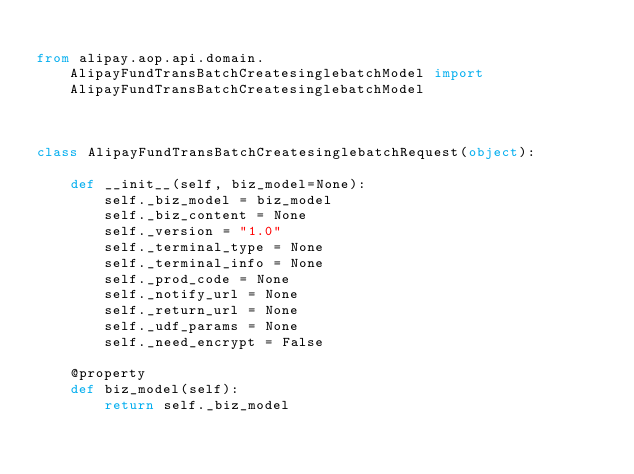Convert code to text. <code><loc_0><loc_0><loc_500><loc_500><_Python_>
from alipay.aop.api.domain.AlipayFundTransBatchCreatesinglebatchModel import AlipayFundTransBatchCreatesinglebatchModel



class AlipayFundTransBatchCreatesinglebatchRequest(object):

    def __init__(self, biz_model=None):
        self._biz_model = biz_model
        self._biz_content = None
        self._version = "1.0"
        self._terminal_type = None
        self._terminal_info = None
        self._prod_code = None
        self._notify_url = None
        self._return_url = None
        self._udf_params = None
        self._need_encrypt = False

    @property
    def biz_model(self):
        return self._biz_model
</code> 